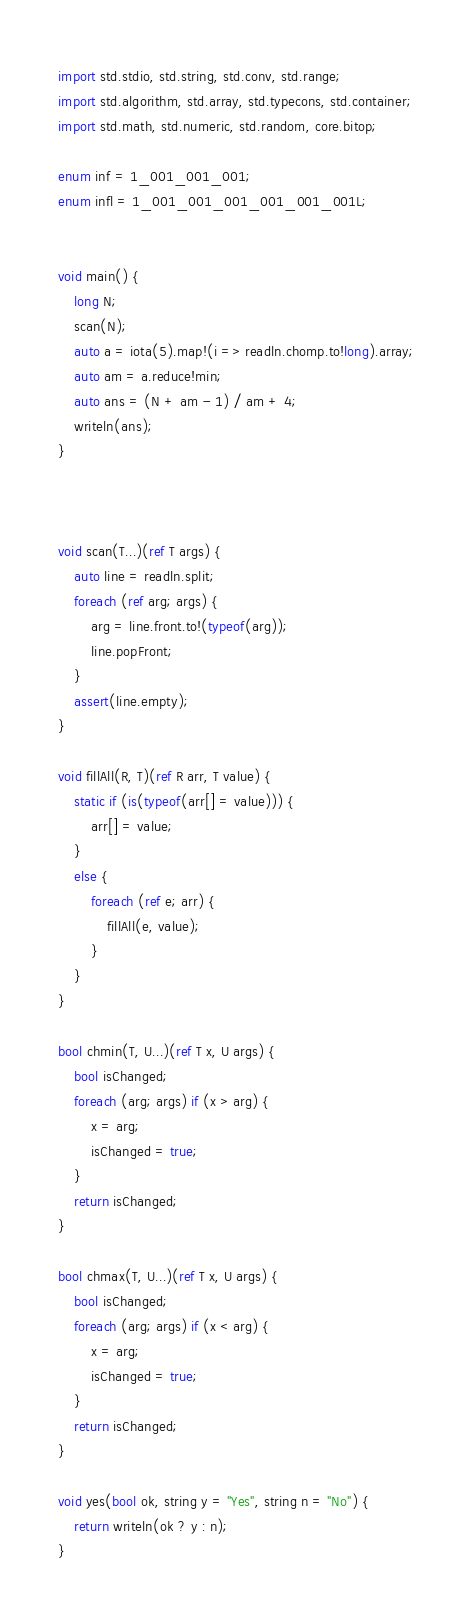<code> <loc_0><loc_0><loc_500><loc_500><_D_>import std.stdio, std.string, std.conv, std.range;
import std.algorithm, std.array, std.typecons, std.container;
import std.math, std.numeric, std.random, core.bitop;

enum inf = 1_001_001_001;
enum infl = 1_001_001_001_001_001_001L;


void main() {
    long N;
    scan(N);
    auto a = iota(5).map!(i => readln.chomp.to!long).array;
    auto am = a.reduce!min;
    auto ans = (N + am - 1) / am + 4;
    writeln(ans);
}



void scan(T...)(ref T args) {
    auto line = readln.split;
    foreach (ref arg; args) {
        arg = line.front.to!(typeof(arg));
        line.popFront;
    }
    assert(line.empty);
}

void fillAll(R, T)(ref R arr, T value) {
    static if (is(typeof(arr[] = value))) {
        arr[] = value;
    }
    else {
        foreach (ref e; arr) {
            fillAll(e, value);
        }
    }
}

bool chmin(T, U...)(ref T x, U args) {
    bool isChanged;
    foreach (arg; args) if (x > arg) {
        x = arg;
        isChanged = true;
    }
    return isChanged;
}

bool chmax(T, U...)(ref T x, U args) {
    bool isChanged;
    foreach (arg; args) if (x < arg) {
        x = arg;
        isChanged = true;
    }
    return isChanged;
}

void yes(bool ok, string y = "Yes", string n = "No") {
    return writeln(ok ? y : n);
}
</code> 